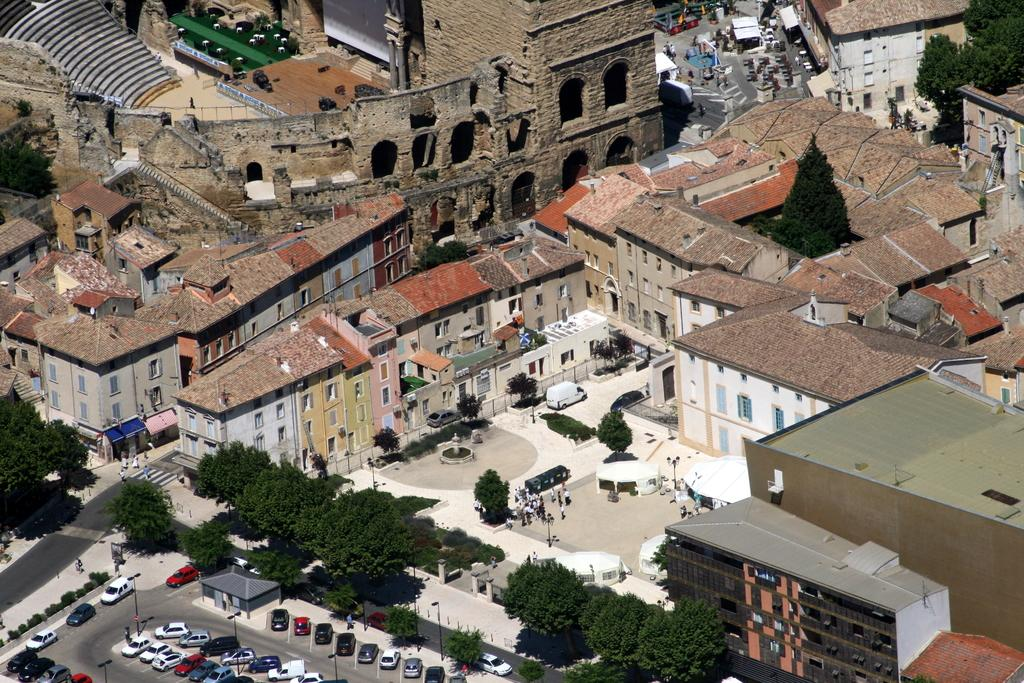What type of structures can be seen in the image? There are many buildings in the image. What natural elements are present in the image? There are trees and plants in the image. What man-made objects can be seen in the image? There are poles and cars in the image. What is the primary mode of transportation visible in the image? Cars are visible in the image. What type of surface is present for vehicles to travel on? There is a road in the image. Are there any living beings present in the image? Yes, there are people in the image. What type of grass is growing on the shirt of the person in the image? There is no mention of a shirt or grass in the image; it features buildings, trees, poles, cars, a road, plants, and people. 